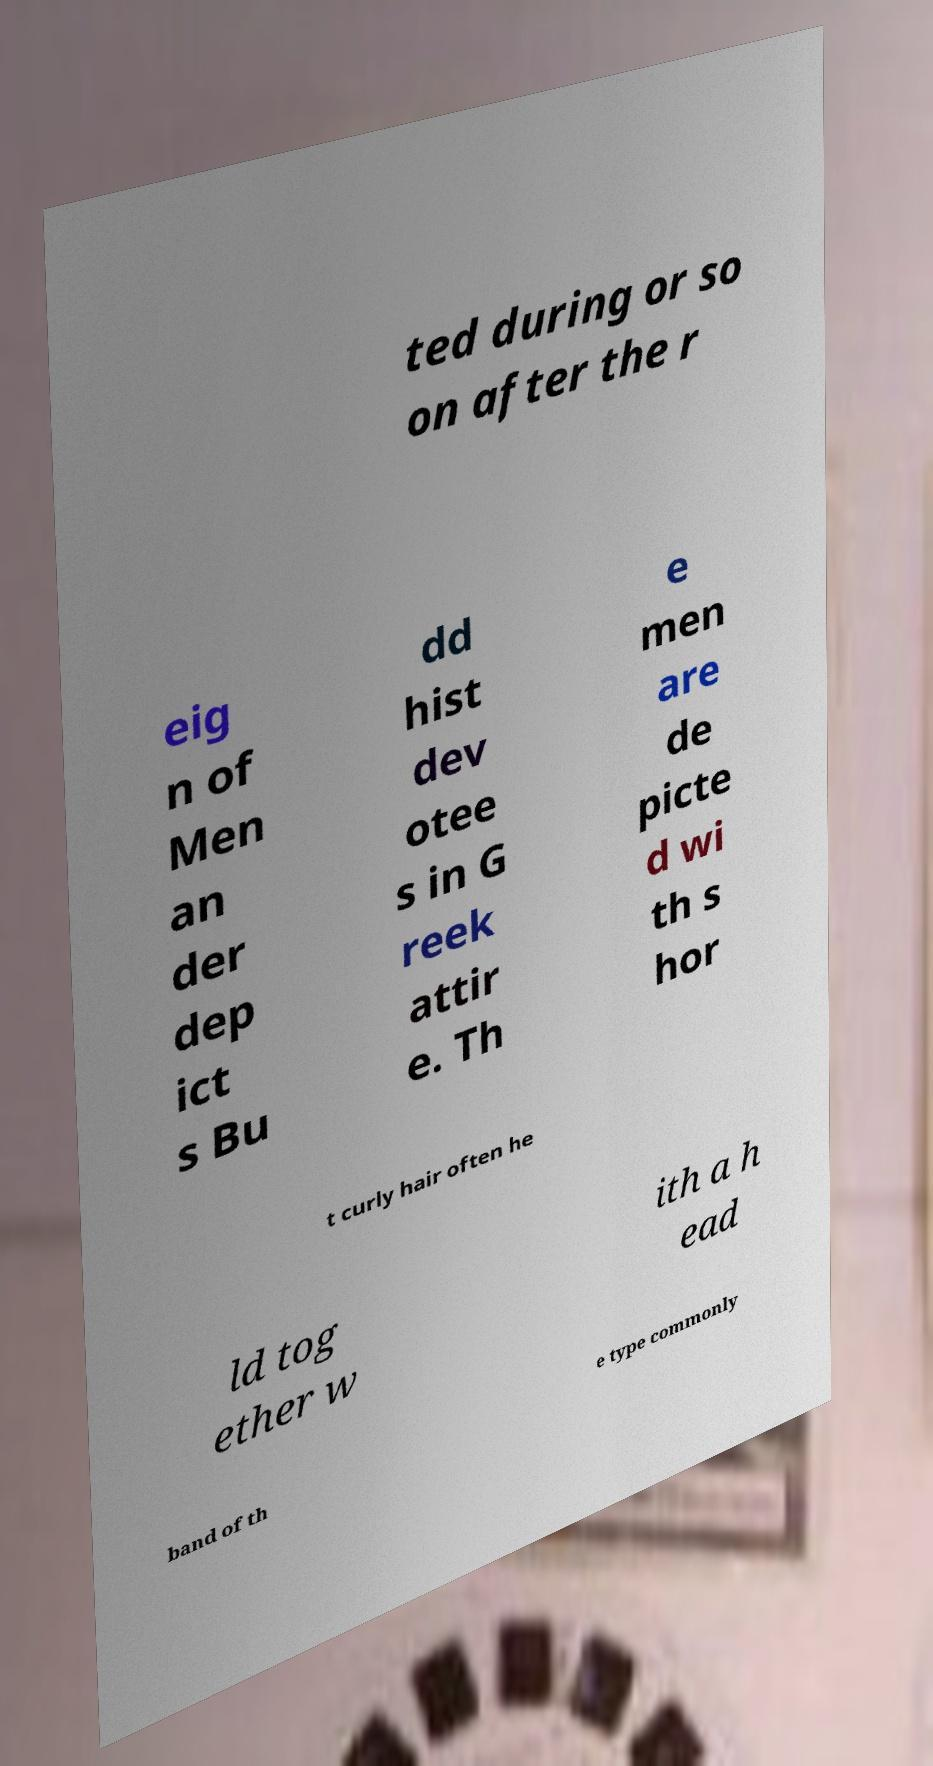Please identify and transcribe the text found in this image. ted during or so on after the r eig n of Men an der dep ict s Bu dd hist dev otee s in G reek attir e. Th e men are de picte d wi th s hor t curly hair often he ld tog ether w ith a h ead band of th e type commonly 